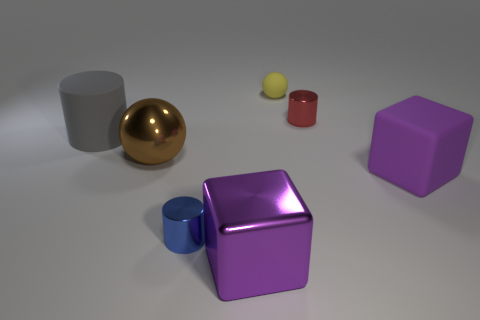Subtract all small red cylinders. How many cylinders are left? 2 Subtract all brown balls. How many balls are left? 1 Add 1 large purple metal cylinders. How many objects exist? 8 Subtract 0 brown cylinders. How many objects are left? 7 Subtract all cubes. How many objects are left? 5 Subtract 3 cylinders. How many cylinders are left? 0 Subtract all brown cylinders. Subtract all red balls. How many cylinders are left? 3 Subtract all gray cylinders. Subtract all tiny yellow rubber objects. How many objects are left? 5 Add 1 gray matte cylinders. How many gray matte cylinders are left? 2 Add 2 small blue metal objects. How many small blue metal objects exist? 3 